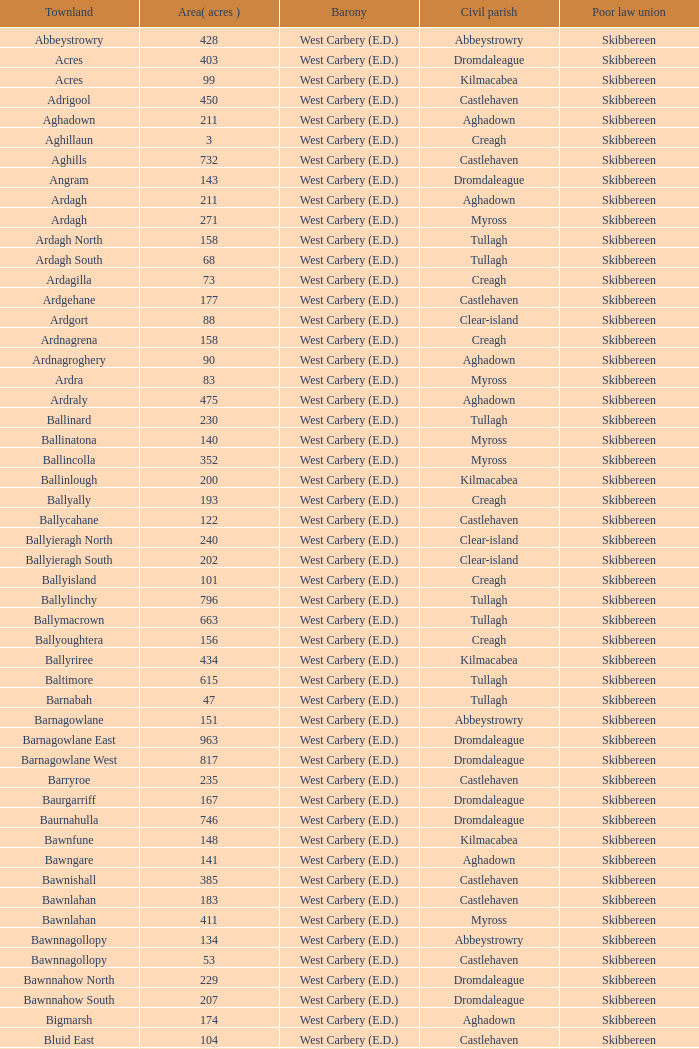What are the Poor Law Unions when the area (in acres) is 142? Skibbereen. 